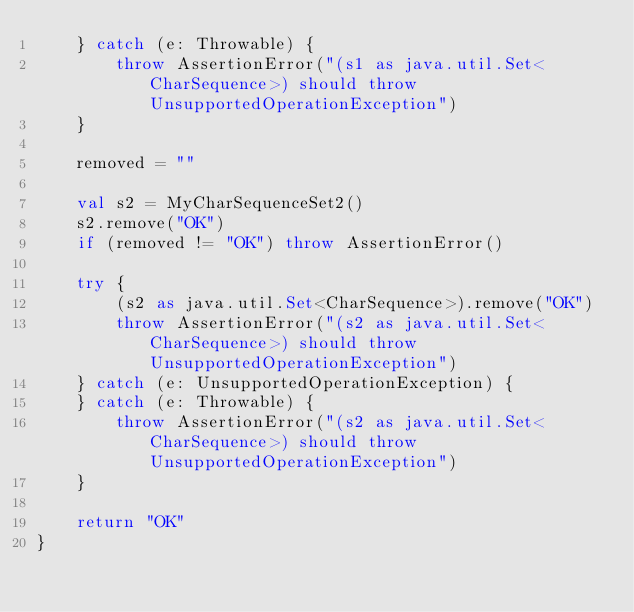<code> <loc_0><loc_0><loc_500><loc_500><_Kotlin_>    } catch (e: Throwable) {
        throw AssertionError("(s1 as java.util.Set<CharSequence>) should throw UnsupportedOperationException")
    }

    removed = ""

    val s2 = MyCharSequenceSet2()
    s2.remove("OK")
    if (removed != "OK") throw AssertionError()

    try {
        (s2 as java.util.Set<CharSequence>).remove("OK")
        throw AssertionError("(s2 as java.util.Set<CharSequence>) should throw UnsupportedOperationException")
    } catch (e: UnsupportedOperationException) {
    } catch (e: Throwable) {
        throw AssertionError("(s2 as java.util.Set<CharSequence>) should throw UnsupportedOperationException")
    }

    return "OK"
}</code> 